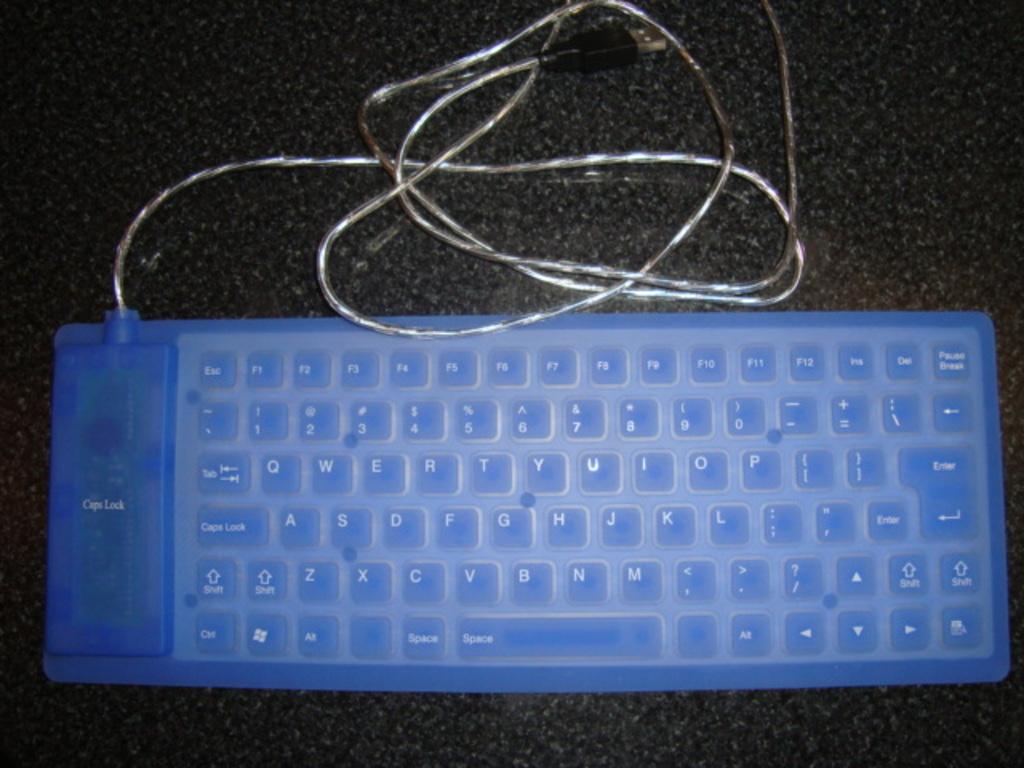Is there an enter key on this keyboard?
Make the answer very short. Yes. What text is on the really big key on the left?
Keep it short and to the point. Caps lock. 